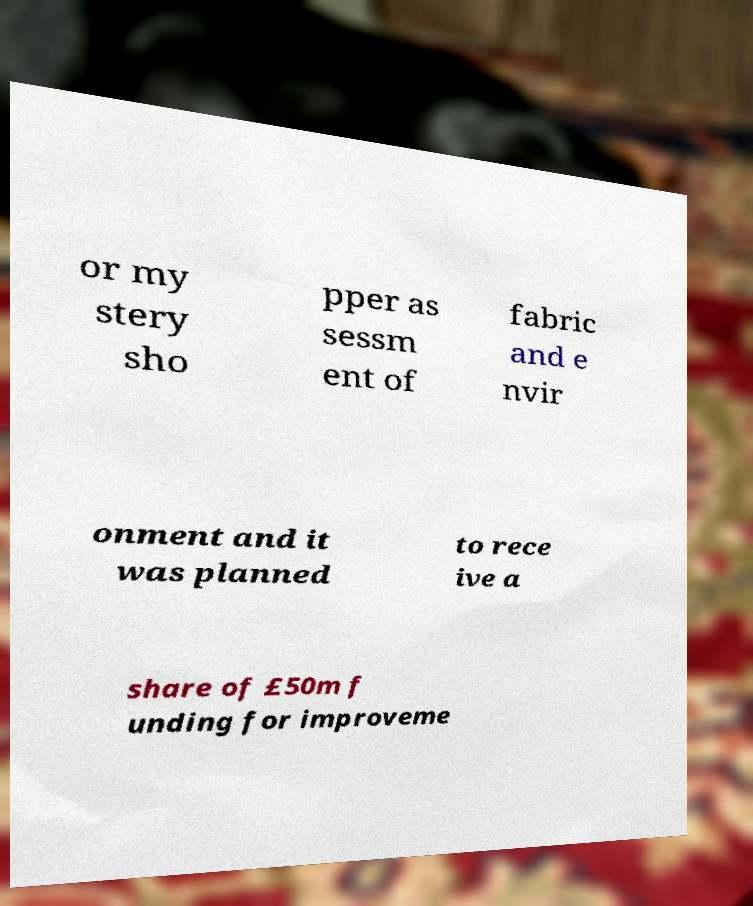What messages or text are displayed in this image? I need them in a readable, typed format. or my stery sho pper as sessm ent of fabric and e nvir onment and it was planned to rece ive a share of £50m f unding for improveme 